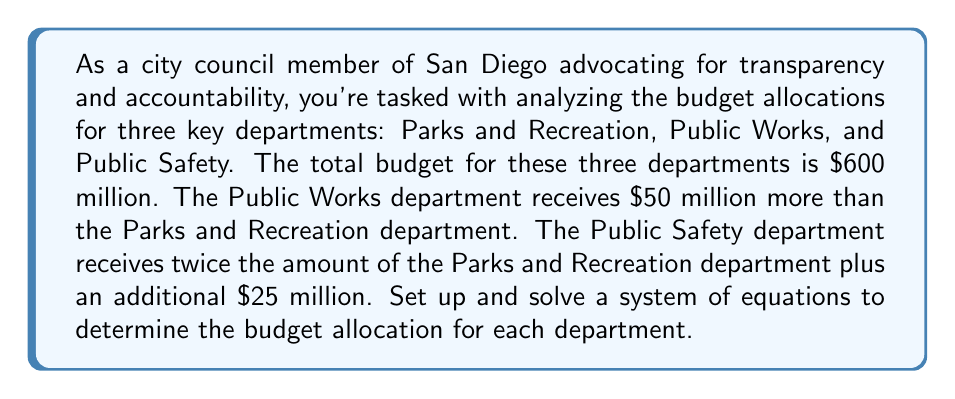Teach me how to tackle this problem. Let's define our variables:
$x$ = Parks and Recreation budget
$y$ = Public Works budget
$z$ = Public Safety budget

From the given information, we can set up three equations:

1. Total budget equation:
   $$x + y + z = 600$$

2. Public Works relation to Parks and Recreation:
   $$y = x + 50$$

3. Public Safety relation to Parks and Recreation:
   $$z = 2x + 25$$

Now, let's solve this system of equations:

Step 1: Substitute equations 2 and 3 into equation 1
$$(x) + (x + 50) + (2x + 25) = 600$$

Step 2: Simplify
$$4x + 75 = 600$$

Step 3: Solve for x
$$4x = 525$$
$$x = 131.25$$

Step 4: Calculate y and z using equations 2 and 3
$$y = 131.25 + 50 = 181.25$$
$$z = 2(131.25) + 25 = 287.5$$

Step 5: Verify the solution
$$131.25 + 181.25 + 287.5 = 600$$

Therefore, the budget allocations are:
Parks and Recreation: $131.25 million
Public Works: $181.25 million
Public Safety: $287.5 million
Answer: Parks and Recreation: $131.25 million
Public Works: $181.25 million
Public Safety: $287.5 million 